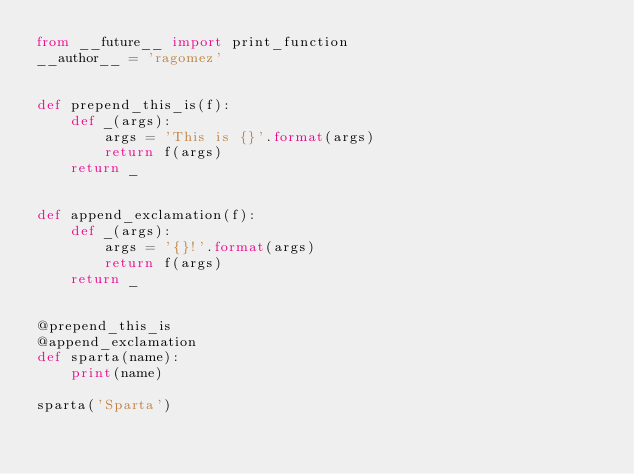<code> <loc_0><loc_0><loc_500><loc_500><_Python_>from __future__ import print_function
__author__ = 'ragomez'


def prepend_this_is(f):
    def _(args):
        args = 'This is {}'.format(args)
        return f(args)
    return _


def append_exclamation(f):
    def _(args):
        args = '{}!'.format(args)
        return f(args)
    return _


@prepend_this_is
@append_exclamation
def sparta(name):
    print(name)

sparta('Sparta')</code> 